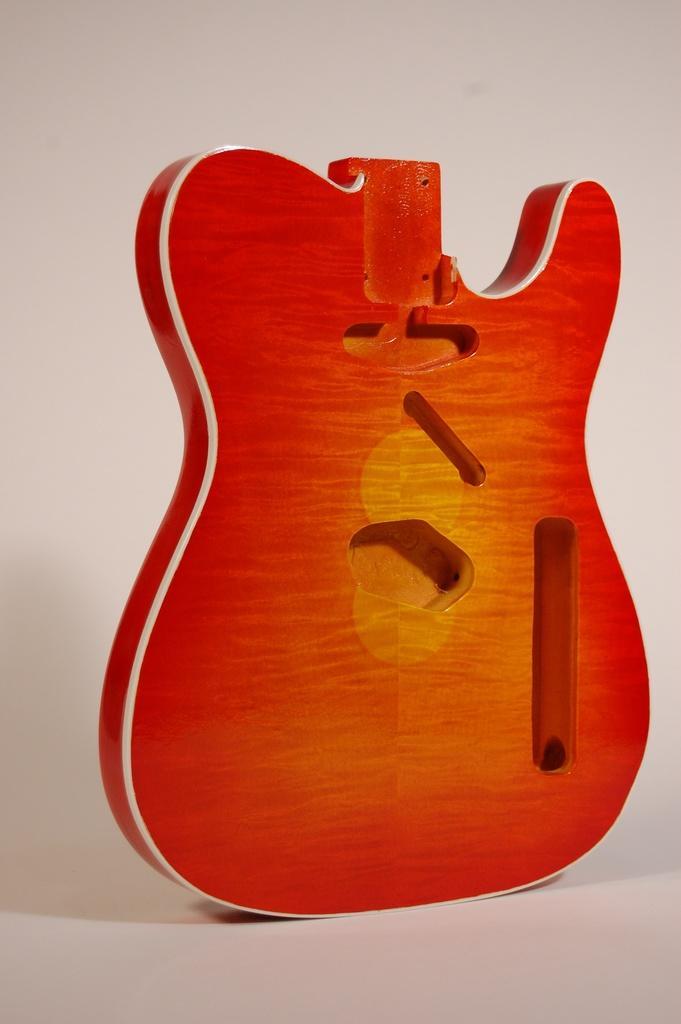Please provide a concise description of this image. In this image I can see a part of a guitar which is yellow and orange in color on the white colored surface and I can see the white colored background. 